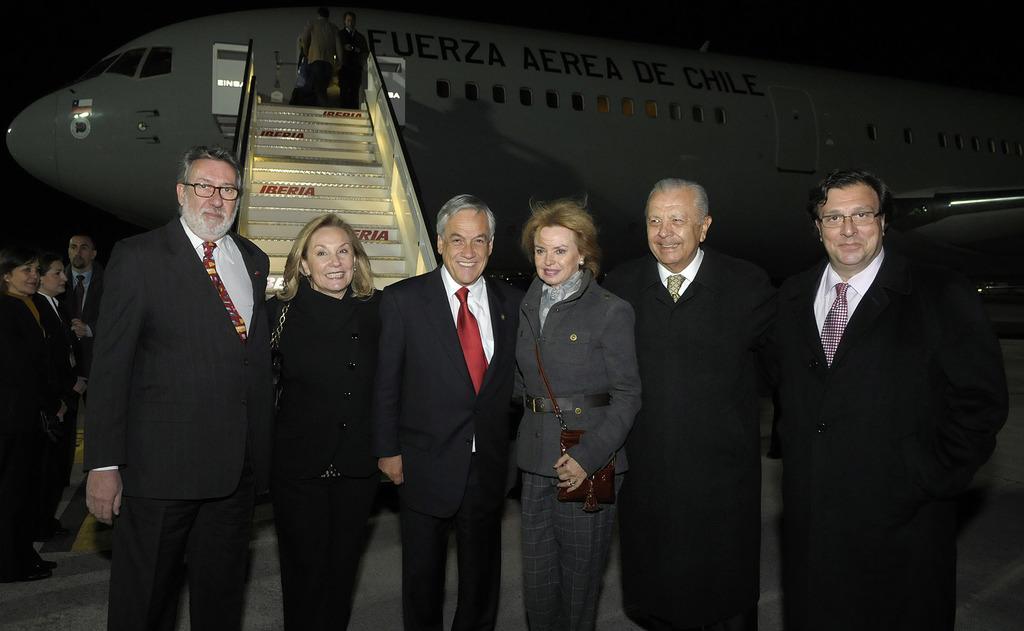Please provide a concise description of this image. In this picture, we can see a group of people standing on the path and behind the people there is an airplane and stairs and there is a dark background. 